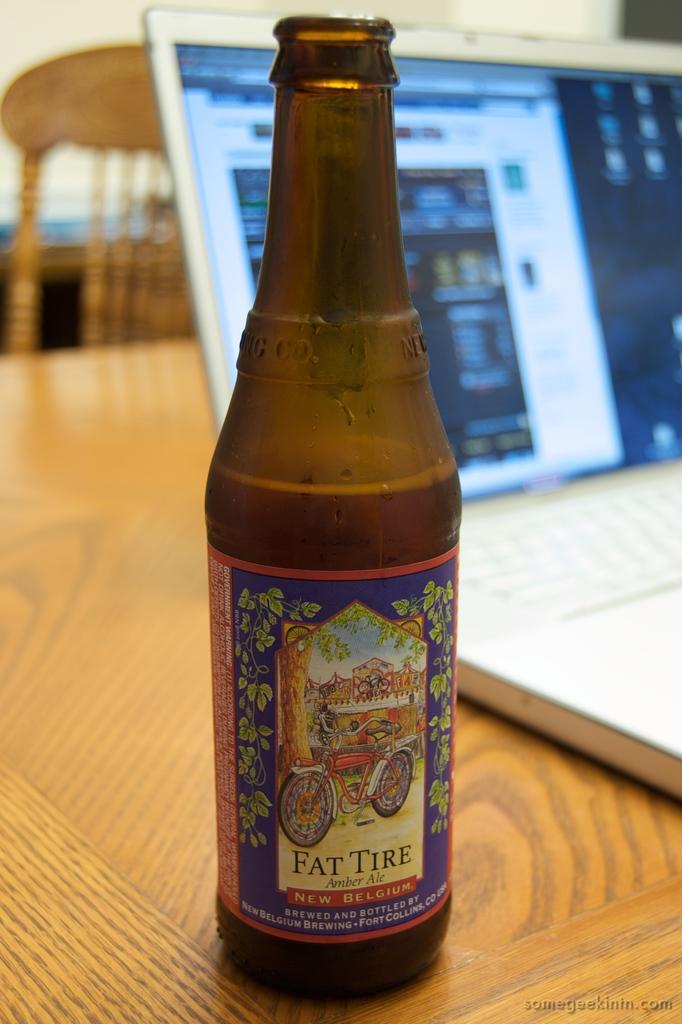What brand of beer is this?
Make the answer very short. Fat tire. What kind of ale is this?
Provide a short and direct response. Amber. 